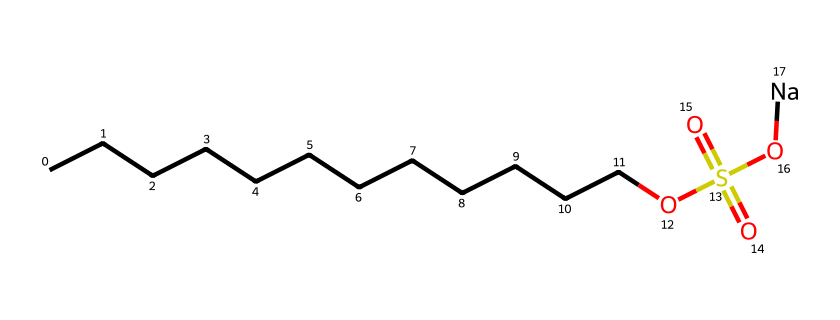how many carbon atoms are present in the compound? In the SMILES representation, the "CCCCCCCCCCCC" part indicates a continuous chain of carbon atoms. Counting the "C" characters gives us a total of 12 carbon atoms.
Answer: 12 what type of functional group is present in the compound? The "OS(=O)(=O)" part of the structure indicates the presence of a sulfonate functional group, which is a characteristic feature of organosulfur compounds.
Answer: sulfonate how many oxygen atoms are in this compound? From the structural representation, we can count the number of "O" symbols: there are four (two in the sulfonate group and one in the hydroxyl part).
Answer: 4 what is the role of sodium in this compound? The "[Na]" at the end of the SMILES indicates that sodium is a counterion that balances the negative charge of the sulfonate group, making the compound a sodium sulfonate.
Answer: counterion what is the total number of hydrogen atoms in the compound? For hydrogen atoms, we can deduce by calculating the maximum number of hydrogens for aliphatic compounds. Each carbon can typically bond with 2 hydrogens, and with 12 carbons, we can calculate (2*12)+1 (from the hydroxyl) - 1 (for the charge on the sulfonate), totaling 25.
Answer: 25 what type of reaction can this compound primarily undergo? This organosulfur compound can participate in sulfonation reactions due to the presence of the sulfonate group, which is common in functionalized organic compounds.
Answer: sulfonation what property of sulfonate compounds makes them useful in cleaning solutions? Sulfonate groups increase the solubility of compounds in water and enhance surfactant properties, making them effective in cleaning solutions for breaking down oils and dirt.
Answer: surfactant properties 